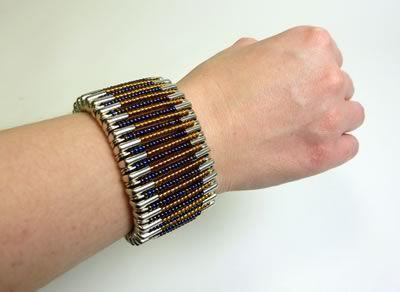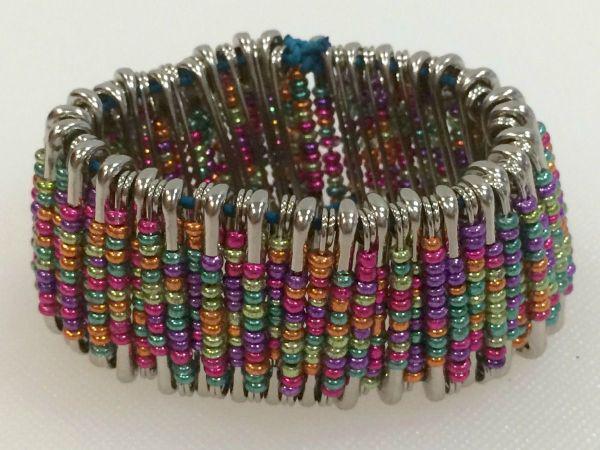The first image is the image on the left, the second image is the image on the right. Assess this claim about the two images: "A bracelet is being modeled in the image on the left.". Correct or not? Answer yes or no. Yes. The first image is the image on the left, the second image is the image on the right. Considering the images on both sides, is "The left image contains a persons wrist modeling a bracelet with many beads." valid? Answer yes or no. Yes. 